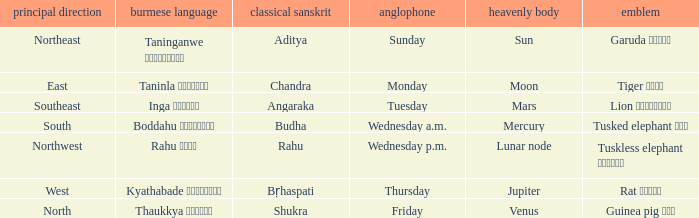What is the planet associated with the direction of south? Mercury. 